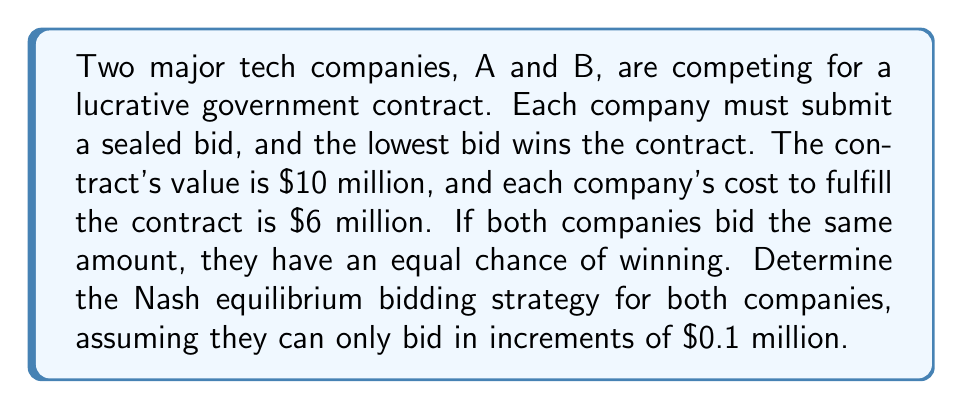Show me your answer to this math problem. To solve this problem, we need to analyze the strategic interactions between the two companies using game theory principles. Let's approach this step-by-step:

1) First, we need to understand the payoff structure:
   - If a company wins, its payoff is (Bid Amount - Cost)
   - If a company loses, its payoff is 0
   - If there's a tie, each company has a 50% chance of winning

2) The maximum bid that makes sense is $10 million (the contract value), and the minimum bid is $6 million (the cost).

3) Let's consider the strategy of undercutting:
   - If Company A bids $x million, Company B's best response is to bid $(x - 0.1)$ million, as long as $x > 6.1$ million.
   - This creates a downward pressure on bids.

4) The Nash equilibrium occurs when neither company has an incentive to change its strategy unilaterally.

5) In this case, the Nash equilibrium is for both companies to bid $6.1 million. Here's why:
   - If either company bids higher, the other company can undercut and win the contract.
   - If either company bids lower ($6 million), it would be operating at zero profit.

6) At $6.1 million bid:
   - Expected payoff if they tie: $0.5 * (6.1 - 6) = $0.05$ million
   - Payoff if they lower bid to $6 million: $6 - 6 = $0$ million

7) Therefore, neither company has an incentive to deviate from bidding $6.1 million.

The Nash equilibrium strategy can be expressed mathematically as:

$$(s_A, s_B) = (6.1, 6.1)$$

Where $s_A$ and $s_B$ are the bidding strategies for Company A and Company B respectively, in millions of dollars.
Answer: The Nash equilibrium bidding strategy for both companies is to bid $6.1 million. 